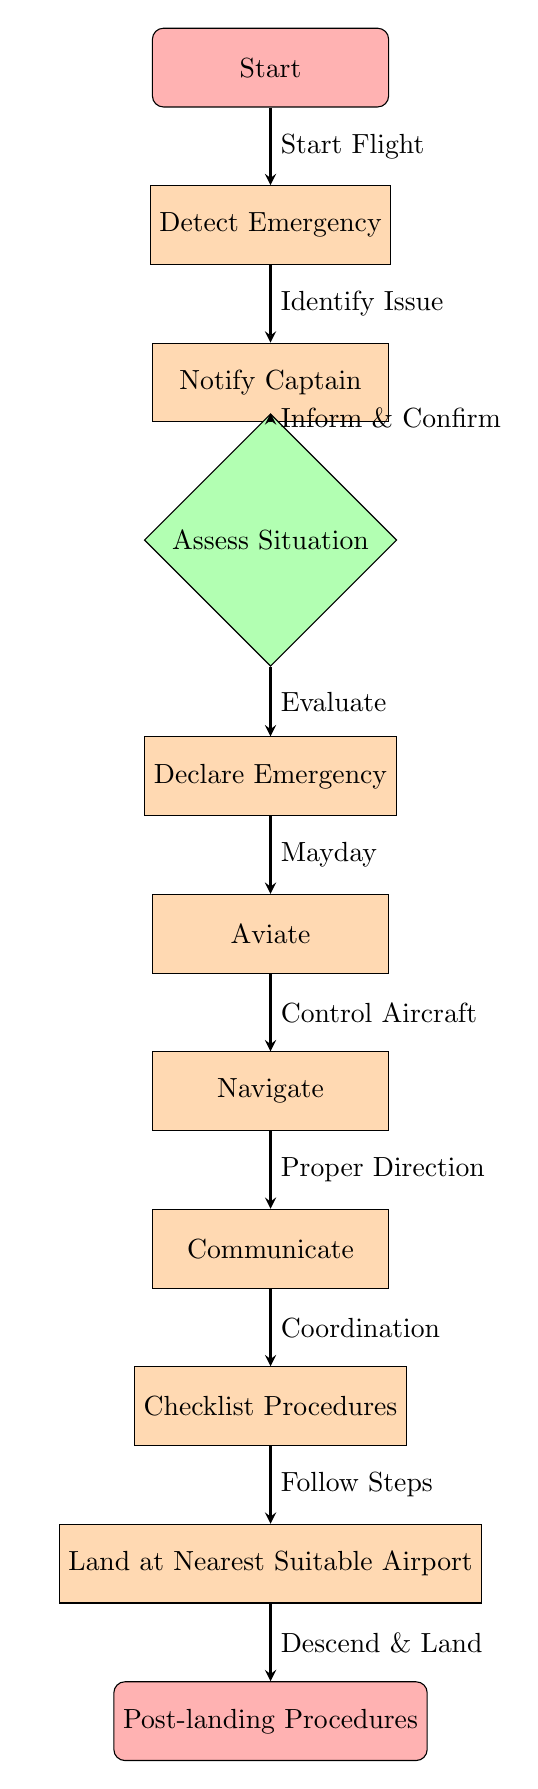What is the first step in this emergency procedure? The diagram starts with the 'Start' node, indicating that the first step is to initiate the process.
Answer: Start How many main process nodes are present in the diagram? The main process nodes include 'Detect Emergency', 'Notify Captain', 'Declare Emergency', 'Aviate', 'Navigate', 'Communicate', 'Checklist Procedures', and 'Land at Nearest Suitable Airport', totaling 8 nodes.
Answer: 8 What action follows the assessment of the situation? After assessing the situation, the next action stated in the diagram is to 'Declare Emergency'.
Answer: Declare Emergency What decision is made after notifying the captain? The decision made after notifying the captain is to 'Assess Situation'.
Answer: Assess Situation What is the final step in the checklist shown in the diagram? The final step in the checklist is 'Post-landing Procedures', which follows after landing the aircraft.
Answer: Post-landing Procedures Which action comes before 'Navigate'? The action that comes before 'Navigate' is 'Aviate', indicating that controlling the aircraft is necessary prior to navigating.
Answer: Aviate What is the relationship between 'Communicate' and 'Checklist Procedures'? 'Communicate' flows directly into 'Checklist Procedures', indicating that communication must occur in conjunction with following the checklist.
Answer: Coordination What does the arrow from 'Declare Emergency' indicate? The arrow from 'Declare Emergency' indicates that a 'Mayday' call is made as a direct result of declaring the emergency.
Answer: Mayday 